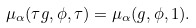<formula> <loc_0><loc_0><loc_500><loc_500>\mu _ { \alpha } ( \tau g , \phi , \tau ) = \mu _ { \alpha } ( g , \phi , 1 ) .</formula> 